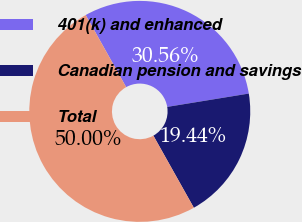Convert chart to OTSL. <chart><loc_0><loc_0><loc_500><loc_500><pie_chart><fcel>401(k) and enhanced<fcel>Canadian pension and savings<fcel>Total<nl><fcel>30.56%<fcel>19.44%<fcel>50.0%<nl></chart> 